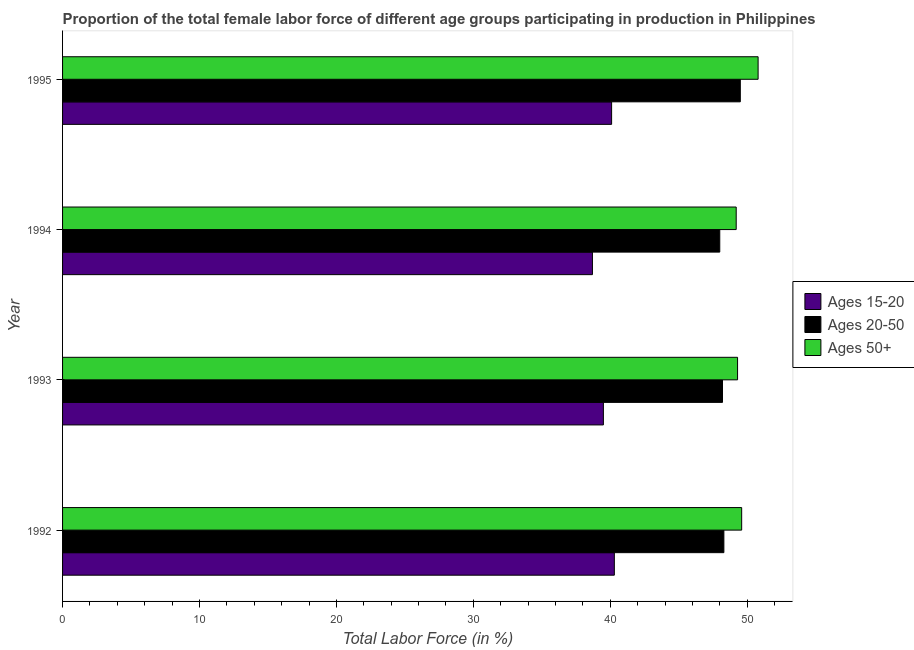Are the number of bars per tick equal to the number of legend labels?
Ensure brevity in your answer.  Yes. Are the number of bars on each tick of the Y-axis equal?
Ensure brevity in your answer.  Yes. How many bars are there on the 2nd tick from the top?
Your response must be concise. 3. What is the percentage of female labor force within the age group 15-20 in 1992?
Offer a very short reply. 40.3. Across all years, what is the maximum percentage of female labor force within the age group 20-50?
Offer a terse response. 49.5. In which year was the percentage of female labor force above age 50 maximum?
Keep it short and to the point. 1995. In which year was the percentage of female labor force within the age group 15-20 minimum?
Your response must be concise. 1994. What is the total percentage of female labor force within the age group 20-50 in the graph?
Offer a terse response. 194. What is the difference between the percentage of female labor force within the age group 20-50 in 1995 and the percentage of female labor force within the age group 15-20 in 1993?
Provide a succinct answer. 10. What is the average percentage of female labor force above age 50 per year?
Offer a terse response. 49.73. In the year 1994, what is the difference between the percentage of female labor force above age 50 and percentage of female labor force within the age group 15-20?
Keep it short and to the point. 10.5. In how many years, is the percentage of female labor force within the age group 15-20 greater than 30 %?
Provide a succinct answer. 4. Is the difference between the percentage of female labor force within the age group 15-20 in 1992 and 1995 greater than the difference between the percentage of female labor force above age 50 in 1992 and 1995?
Ensure brevity in your answer.  Yes. What does the 2nd bar from the top in 1995 represents?
Make the answer very short. Ages 20-50. What does the 1st bar from the bottom in 1994 represents?
Your answer should be very brief. Ages 15-20. How many bars are there?
Make the answer very short. 12. Does the graph contain grids?
Keep it short and to the point. No. Where does the legend appear in the graph?
Your answer should be compact. Center right. How are the legend labels stacked?
Keep it short and to the point. Vertical. What is the title of the graph?
Your response must be concise. Proportion of the total female labor force of different age groups participating in production in Philippines. Does "ICT services" appear as one of the legend labels in the graph?
Your response must be concise. No. What is the label or title of the Y-axis?
Make the answer very short. Year. What is the Total Labor Force (in %) in Ages 15-20 in 1992?
Provide a short and direct response. 40.3. What is the Total Labor Force (in %) in Ages 20-50 in 1992?
Give a very brief answer. 48.3. What is the Total Labor Force (in %) in Ages 50+ in 1992?
Provide a short and direct response. 49.6. What is the Total Labor Force (in %) of Ages 15-20 in 1993?
Provide a succinct answer. 39.5. What is the Total Labor Force (in %) of Ages 20-50 in 1993?
Your answer should be compact. 48.2. What is the Total Labor Force (in %) of Ages 50+ in 1993?
Keep it short and to the point. 49.3. What is the Total Labor Force (in %) of Ages 15-20 in 1994?
Keep it short and to the point. 38.7. What is the Total Labor Force (in %) in Ages 50+ in 1994?
Your answer should be compact. 49.2. What is the Total Labor Force (in %) of Ages 15-20 in 1995?
Ensure brevity in your answer.  40.1. What is the Total Labor Force (in %) of Ages 20-50 in 1995?
Give a very brief answer. 49.5. What is the Total Labor Force (in %) in Ages 50+ in 1995?
Keep it short and to the point. 50.8. Across all years, what is the maximum Total Labor Force (in %) of Ages 15-20?
Offer a very short reply. 40.3. Across all years, what is the maximum Total Labor Force (in %) in Ages 20-50?
Offer a terse response. 49.5. Across all years, what is the maximum Total Labor Force (in %) of Ages 50+?
Your answer should be very brief. 50.8. Across all years, what is the minimum Total Labor Force (in %) in Ages 15-20?
Your answer should be very brief. 38.7. Across all years, what is the minimum Total Labor Force (in %) of Ages 50+?
Your answer should be compact. 49.2. What is the total Total Labor Force (in %) in Ages 15-20 in the graph?
Your answer should be very brief. 158.6. What is the total Total Labor Force (in %) in Ages 20-50 in the graph?
Offer a terse response. 194. What is the total Total Labor Force (in %) of Ages 50+ in the graph?
Your answer should be very brief. 198.9. What is the difference between the Total Labor Force (in %) of Ages 20-50 in 1992 and that in 1993?
Provide a short and direct response. 0.1. What is the difference between the Total Labor Force (in %) in Ages 50+ in 1992 and that in 1994?
Make the answer very short. 0.4. What is the difference between the Total Labor Force (in %) of Ages 50+ in 1992 and that in 1995?
Provide a short and direct response. -1.2. What is the difference between the Total Labor Force (in %) in Ages 20-50 in 1993 and that in 1994?
Give a very brief answer. 0.2. What is the difference between the Total Labor Force (in %) in Ages 15-20 in 1993 and that in 1995?
Ensure brevity in your answer.  -0.6. What is the difference between the Total Labor Force (in %) in Ages 50+ in 1993 and that in 1995?
Give a very brief answer. -1.5. What is the difference between the Total Labor Force (in %) in Ages 15-20 in 1994 and that in 1995?
Offer a terse response. -1.4. What is the difference between the Total Labor Force (in %) of Ages 50+ in 1994 and that in 1995?
Provide a succinct answer. -1.6. What is the difference between the Total Labor Force (in %) of Ages 15-20 in 1992 and the Total Labor Force (in %) of Ages 20-50 in 1993?
Your response must be concise. -7.9. What is the difference between the Total Labor Force (in %) of Ages 15-20 in 1992 and the Total Labor Force (in %) of Ages 20-50 in 1994?
Your response must be concise. -7.7. What is the difference between the Total Labor Force (in %) of Ages 20-50 in 1992 and the Total Labor Force (in %) of Ages 50+ in 1994?
Your response must be concise. -0.9. What is the difference between the Total Labor Force (in %) of Ages 15-20 in 1992 and the Total Labor Force (in %) of Ages 50+ in 1995?
Give a very brief answer. -10.5. What is the difference between the Total Labor Force (in %) of Ages 15-20 in 1993 and the Total Labor Force (in %) of Ages 20-50 in 1994?
Your answer should be very brief. -8.5. What is the difference between the Total Labor Force (in %) of Ages 20-50 in 1993 and the Total Labor Force (in %) of Ages 50+ in 1994?
Keep it short and to the point. -1. What is the difference between the Total Labor Force (in %) of Ages 15-20 in 1993 and the Total Labor Force (in %) of Ages 50+ in 1995?
Provide a succinct answer. -11.3. What is the difference between the Total Labor Force (in %) in Ages 20-50 in 1993 and the Total Labor Force (in %) in Ages 50+ in 1995?
Give a very brief answer. -2.6. What is the difference between the Total Labor Force (in %) of Ages 20-50 in 1994 and the Total Labor Force (in %) of Ages 50+ in 1995?
Keep it short and to the point. -2.8. What is the average Total Labor Force (in %) of Ages 15-20 per year?
Offer a very short reply. 39.65. What is the average Total Labor Force (in %) of Ages 20-50 per year?
Give a very brief answer. 48.5. What is the average Total Labor Force (in %) of Ages 50+ per year?
Your answer should be compact. 49.73. In the year 1992, what is the difference between the Total Labor Force (in %) in Ages 15-20 and Total Labor Force (in %) in Ages 20-50?
Provide a short and direct response. -8. In the year 1992, what is the difference between the Total Labor Force (in %) of Ages 20-50 and Total Labor Force (in %) of Ages 50+?
Provide a short and direct response. -1.3. In the year 1993, what is the difference between the Total Labor Force (in %) in Ages 15-20 and Total Labor Force (in %) in Ages 20-50?
Ensure brevity in your answer.  -8.7. In the year 1993, what is the difference between the Total Labor Force (in %) of Ages 20-50 and Total Labor Force (in %) of Ages 50+?
Your answer should be compact. -1.1. In the year 1994, what is the difference between the Total Labor Force (in %) in Ages 15-20 and Total Labor Force (in %) in Ages 20-50?
Provide a succinct answer. -9.3. In the year 1994, what is the difference between the Total Labor Force (in %) of Ages 20-50 and Total Labor Force (in %) of Ages 50+?
Offer a very short reply. -1.2. In the year 1995, what is the difference between the Total Labor Force (in %) of Ages 15-20 and Total Labor Force (in %) of Ages 20-50?
Offer a terse response. -9.4. In the year 1995, what is the difference between the Total Labor Force (in %) in Ages 20-50 and Total Labor Force (in %) in Ages 50+?
Your response must be concise. -1.3. What is the ratio of the Total Labor Force (in %) in Ages 15-20 in 1992 to that in 1993?
Ensure brevity in your answer.  1.02. What is the ratio of the Total Labor Force (in %) of Ages 20-50 in 1992 to that in 1993?
Keep it short and to the point. 1. What is the ratio of the Total Labor Force (in %) in Ages 15-20 in 1992 to that in 1994?
Give a very brief answer. 1.04. What is the ratio of the Total Labor Force (in %) of Ages 15-20 in 1992 to that in 1995?
Your answer should be very brief. 1. What is the ratio of the Total Labor Force (in %) of Ages 20-50 in 1992 to that in 1995?
Provide a succinct answer. 0.98. What is the ratio of the Total Labor Force (in %) of Ages 50+ in 1992 to that in 1995?
Your answer should be very brief. 0.98. What is the ratio of the Total Labor Force (in %) of Ages 15-20 in 1993 to that in 1994?
Ensure brevity in your answer.  1.02. What is the ratio of the Total Labor Force (in %) in Ages 50+ in 1993 to that in 1994?
Your answer should be very brief. 1. What is the ratio of the Total Labor Force (in %) in Ages 15-20 in 1993 to that in 1995?
Your response must be concise. 0.98. What is the ratio of the Total Labor Force (in %) of Ages 20-50 in 1993 to that in 1995?
Make the answer very short. 0.97. What is the ratio of the Total Labor Force (in %) of Ages 50+ in 1993 to that in 1995?
Your response must be concise. 0.97. What is the ratio of the Total Labor Force (in %) of Ages 15-20 in 1994 to that in 1995?
Offer a very short reply. 0.97. What is the ratio of the Total Labor Force (in %) in Ages 20-50 in 1994 to that in 1995?
Ensure brevity in your answer.  0.97. What is the ratio of the Total Labor Force (in %) in Ages 50+ in 1994 to that in 1995?
Ensure brevity in your answer.  0.97. What is the difference between the highest and the second highest Total Labor Force (in %) in Ages 20-50?
Make the answer very short. 1.2. What is the difference between the highest and the lowest Total Labor Force (in %) in Ages 20-50?
Provide a succinct answer. 1.5. 